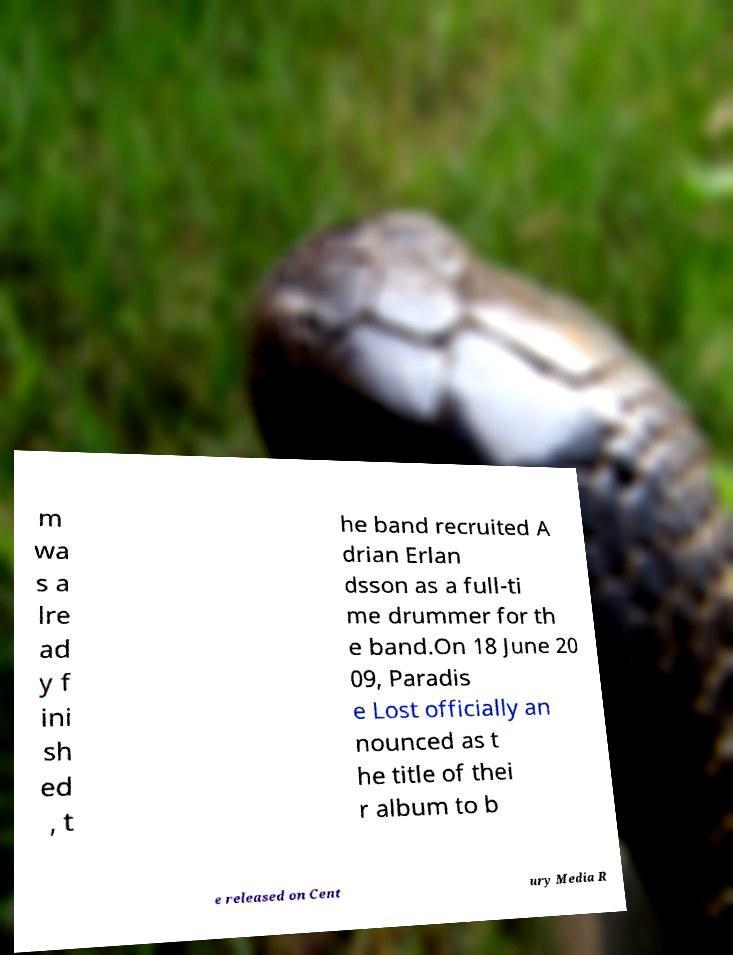There's text embedded in this image that I need extracted. Can you transcribe it verbatim? m wa s a lre ad y f ini sh ed , t he band recruited A drian Erlan dsson as a full-ti me drummer for th e band.On 18 June 20 09, Paradis e Lost officially an nounced as t he title of thei r album to b e released on Cent ury Media R 